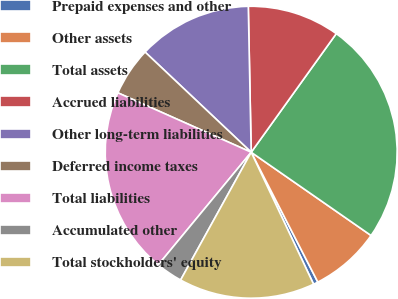Convert chart to OTSL. <chart><loc_0><loc_0><loc_500><loc_500><pie_chart><fcel>Prepaid expenses and other<fcel>Other assets<fcel>Total assets<fcel>Accrued liabilities<fcel>Other long-term liabilities<fcel>Deferred income taxes<fcel>Total liabilities<fcel>Accumulated other<fcel>Total stockholders' equity<nl><fcel>0.52%<fcel>7.79%<fcel>24.76%<fcel>10.22%<fcel>12.64%<fcel>5.37%<fcel>20.69%<fcel>2.95%<fcel>15.06%<nl></chart> 